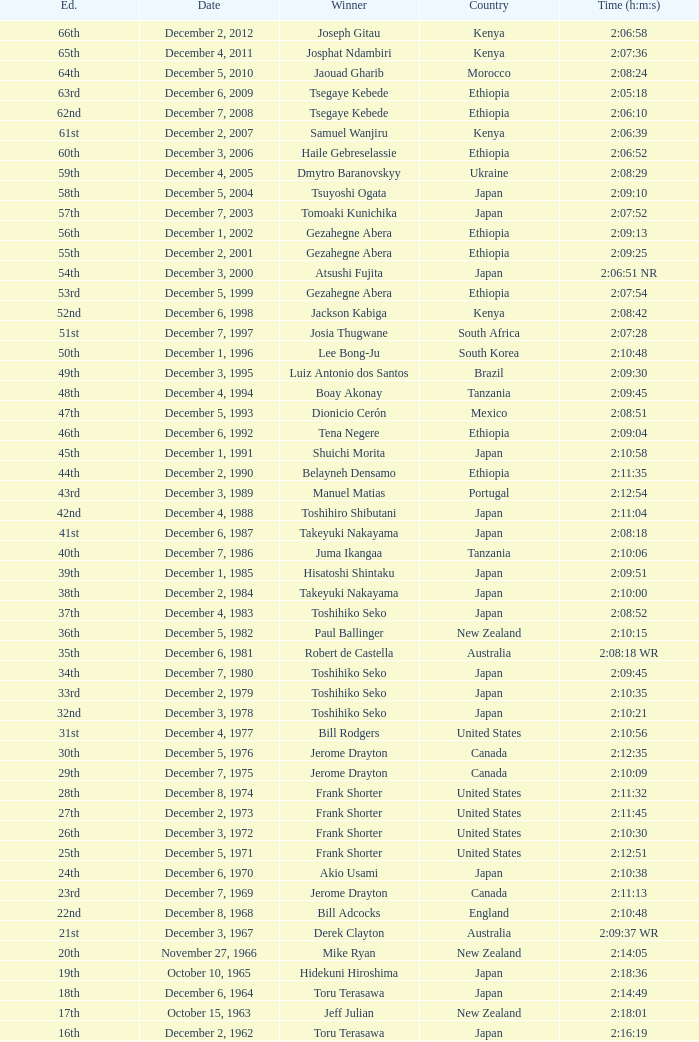What was the nationality of the winner for the 20th Edition? New Zealand. 